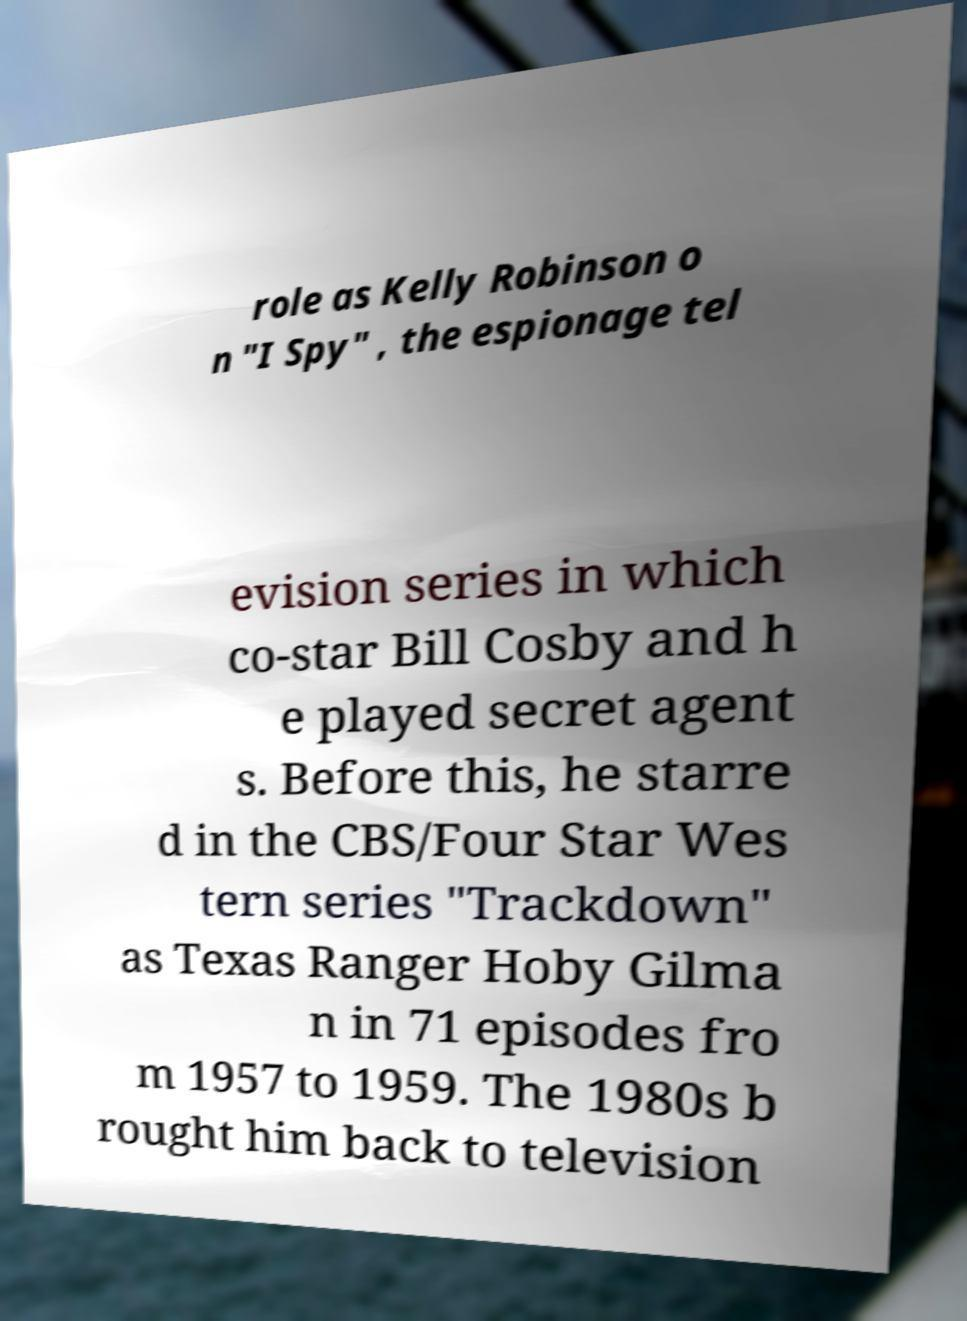Can you accurately transcribe the text from the provided image for me? role as Kelly Robinson o n "I Spy" , the espionage tel evision series in which co-star Bill Cosby and h e played secret agent s. Before this, he starre d in the CBS/Four Star Wes tern series "Trackdown" as Texas Ranger Hoby Gilma n in 71 episodes fro m 1957 to 1959. The 1980s b rought him back to television 